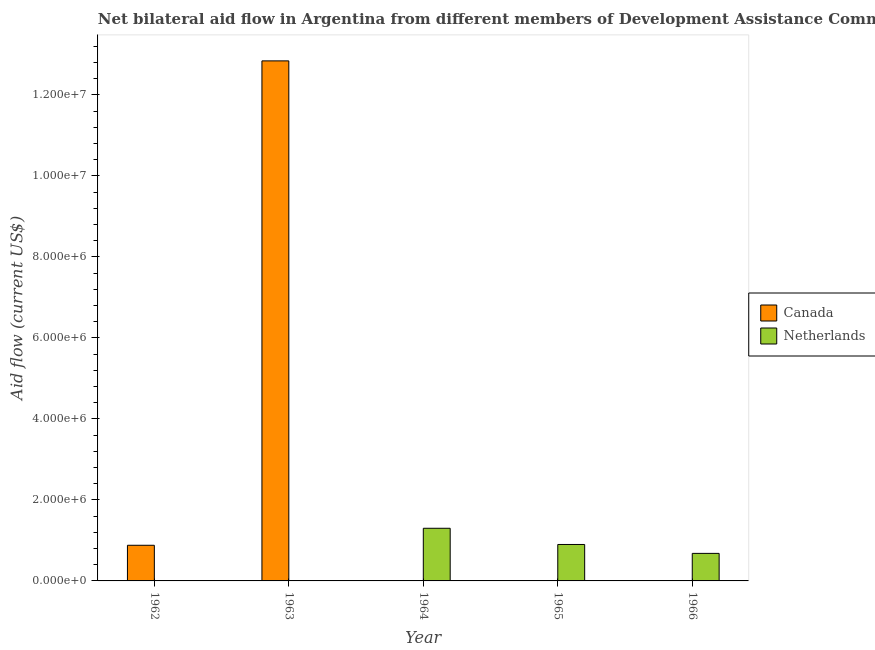How many different coloured bars are there?
Ensure brevity in your answer.  2. How many bars are there on the 2nd tick from the left?
Give a very brief answer. 1. How many bars are there on the 4th tick from the right?
Provide a succinct answer. 1. What is the amount of aid given by netherlands in 1962?
Offer a very short reply. 0. Across all years, what is the maximum amount of aid given by netherlands?
Provide a short and direct response. 1.30e+06. Across all years, what is the minimum amount of aid given by netherlands?
Offer a very short reply. 0. In which year was the amount of aid given by netherlands maximum?
Offer a very short reply. 1964. What is the total amount of aid given by netherlands in the graph?
Your answer should be very brief. 2.88e+06. What is the difference between the amount of aid given by canada in 1962 and that in 1966?
Your answer should be compact. 8.70e+05. What is the difference between the amount of aid given by netherlands in 1962 and the amount of aid given by canada in 1963?
Your answer should be very brief. 0. What is the average amount of aid given by canada per year?
Your answer should be compact. 2.75e+06. In the year 1962, what is the difference between the amount of aid given by canada and amount of aid given by netherlands?
Make the answer very short. 0. What is the ratio of the amount of aid given by canada in 1963 to that in 1966?
Give a very brief answer. 1284. What is the difference between the highest and the second highest amount of aid given by canada?
Give a very brief answer. 1.20e+07. What is the difference between the highest and the lowest amount of aid given by netherlands?
Your answer should be compact. 1.30e+06. Are the values on the major ticks of Y-axis written in scientific E-notation?
Your answer should be compact. Yes. Does the graph contain grids?
Provide a short and direct response. No. Where does the legend appear in the graph?
Offer a very short reply. Center right. How are the legend labels stacked?
Your answer should be very brief. Vertical. What is the title of the graph?
Offer a terse response. Net bilateral aid flow in Argentina from different members of Development Assistance Committee. Does "Nitrous oxide emissions" appear as one of the legend labels in the graph?
Provide a succinct answer. No. What is the label or title of the Y-axis?
Ensure brevity in your answer.  Aid flow (current US$). What is the Aid flow (current US$) in Canada in 1962?
Provide a succinct answer. 8.80e+05. What is the Aid flow (current US$) of Netherlands in 1962?
Keep it short and to the point. 0. What is the Aid flow (current US$) in Canada in 1963?
Keep it short and to the point. 1.28e+07. What is the Aid flow (current US$) of Canada in 1964?
Provide a succinct answer. 0. What is the Aid flow (current US$) in Netherlands in 1964?
Make the answer very short. 1.30e+06. What is the Aid flow (current US$) in Canada in 1965?
Provide a short and direct response. 0. What is the Aid flow (current US$) in Netherlands in 1965?
Make the answer very short. 9.00e+05. What is the Aid flow (current US$) in Canada in 1966?
Give a very brief answer. 10000. What is the Aid flow (current US$) in Netherlands in 1966?
Offer a terse response. 6.80e+05. Across all years, what is the maximum Aid flow (current US$) of Canada?
Ensure brevity in your answer.  1.28e+07. Across all years, what is the maximum Aid flow (current US$) in Netherlands?
Make the answer very short. 1.30e+06. Across all years, what is the minimum Aid flow (current US$) of Canada?
Give a very brief answer. 0. Across all years, what is the minimum Aid flow (current US$) of Netherlands?
Make the answer very short. 0. What is the total Aid flow (current US$) in Canada in the graph?
Provide a succinct answer. 1.37e+07. What is the total Aid flow (current US$) of Netherlands in the graph?
Keep it short and to the point. 2.88e+06. What is the difference between the Aid flow (current US$) of Canada in 1962 and that in 1963?
Make the answer very short. -1.20e+07. What is the difference between the Aid flow (current US$) of Canada in 1962 and that in 1966?
Offer a very short reply. 8.70e+05. What is the difference between the Aid flow (current US$) in Canada in 1963 and that in 1966?
Offer a terse response. 1.28e+07. What is the difference between the Aid flow (current US$) of Netherlands in 1964 and that in 1965?
Offer a very short reply. 4.00e+05. What is the difference between the Aid flow (current US$) in Netherlands in 1964 and that in 1966?
Provide a short and direct response. 6.20e+05. What is the difference between the Aid flow (current US$) in Netherlands in 1965 and that in 1966?
Provide a short and direct response. 2.20e+05. What is the difference between the Aid flow (current US$) of Canada in 1962 and the Aid flow (current US$) of Netherlands in 1964?
Keep it short and to the point. -4.20e+05. What is the difference between the Aid flow (current US$) of Canada in 1962 and the Aid flow (current US$) of Netherlands in 1966?
Your answer should be very brief. 2.00e+05. What is the difference between the Aid flow (current US$) in Canada in 1963 and the Aid flow (current US$) in Netherlands in 1964?
Keep it short and to the point. 1.15e+07. What is the difference between the Aid flow (current US$) of Canada in 1963 and the Aid flow (current US$) of Netherlands in 1965?
Give a very brief answer. 1.19e+07. What is the difference between the Aid flow (current US$) in Canada in 1963 and the Aid flow (current US$) in Netherlands in 1966?
Your answer should be compact. 1.22e+07. What is the average Aid flow (current US$) in Canada per year?
Keep it short and to the point. 2.75e+06. What is the average Aid flow (current US$) of Netherlands per year?
Give a very brief answer. 5.76e+05. In the year 1966, what is the difference between the Aid flow (current US$) in Canada and Aid flow (current US$) in Netherlands?
Provide a short and direct response. -6.70e+05. What is the ratio of the Aid flow (current US$) in Canada in 1962 to that in 1963?
Your answer should be compact. 0.07. What is the ratio of the Aid flow (current US$) of Canada in 1963 to that in 1966?
Keep it short and to the point. 1284. What is the ratio of the Aid flow (current US$) in Netherlands in 1964 to that in 1965?
Offer a terse response. 1.44. What is the ratio of the Aid flow (current US$) in Netherlands in 1964 to that in 1966?
Offer a very short reply. 1.91. What is the ratio of the Aid flow (current US$) of Netherlands in 1965 to that in 1966?
Your answer should be very brief. 1.32. What is the difference between the highest and the second highest Aid flow (current US$) of Canada?
Provide a short and direct response. 1.20e+07. What is the difference between the highest and the second highest Aid flow (current US$) of Netherlands?
Your answer should be very brief. 4.00e+05. What is the difference between the highest and the lowest Aid flow (current US$) of Canada?
Provide a succinct answer. 1.28e+07. What is the difference between the highest and the lowest Aid flow (current US$) in Netherlands?
Your answer should be compact. 1.30e+06. 